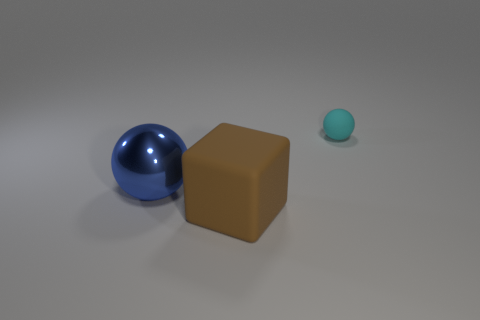What time of day does the lighting in the image suggest? The image has a neutral lighting with soft shadows, which doesn't strongly suggest any particular time of day. It appears to be an artificial, studio-like lighting environment typically used for product visualization, providing even illumination to the objects without mimicking natural light. 